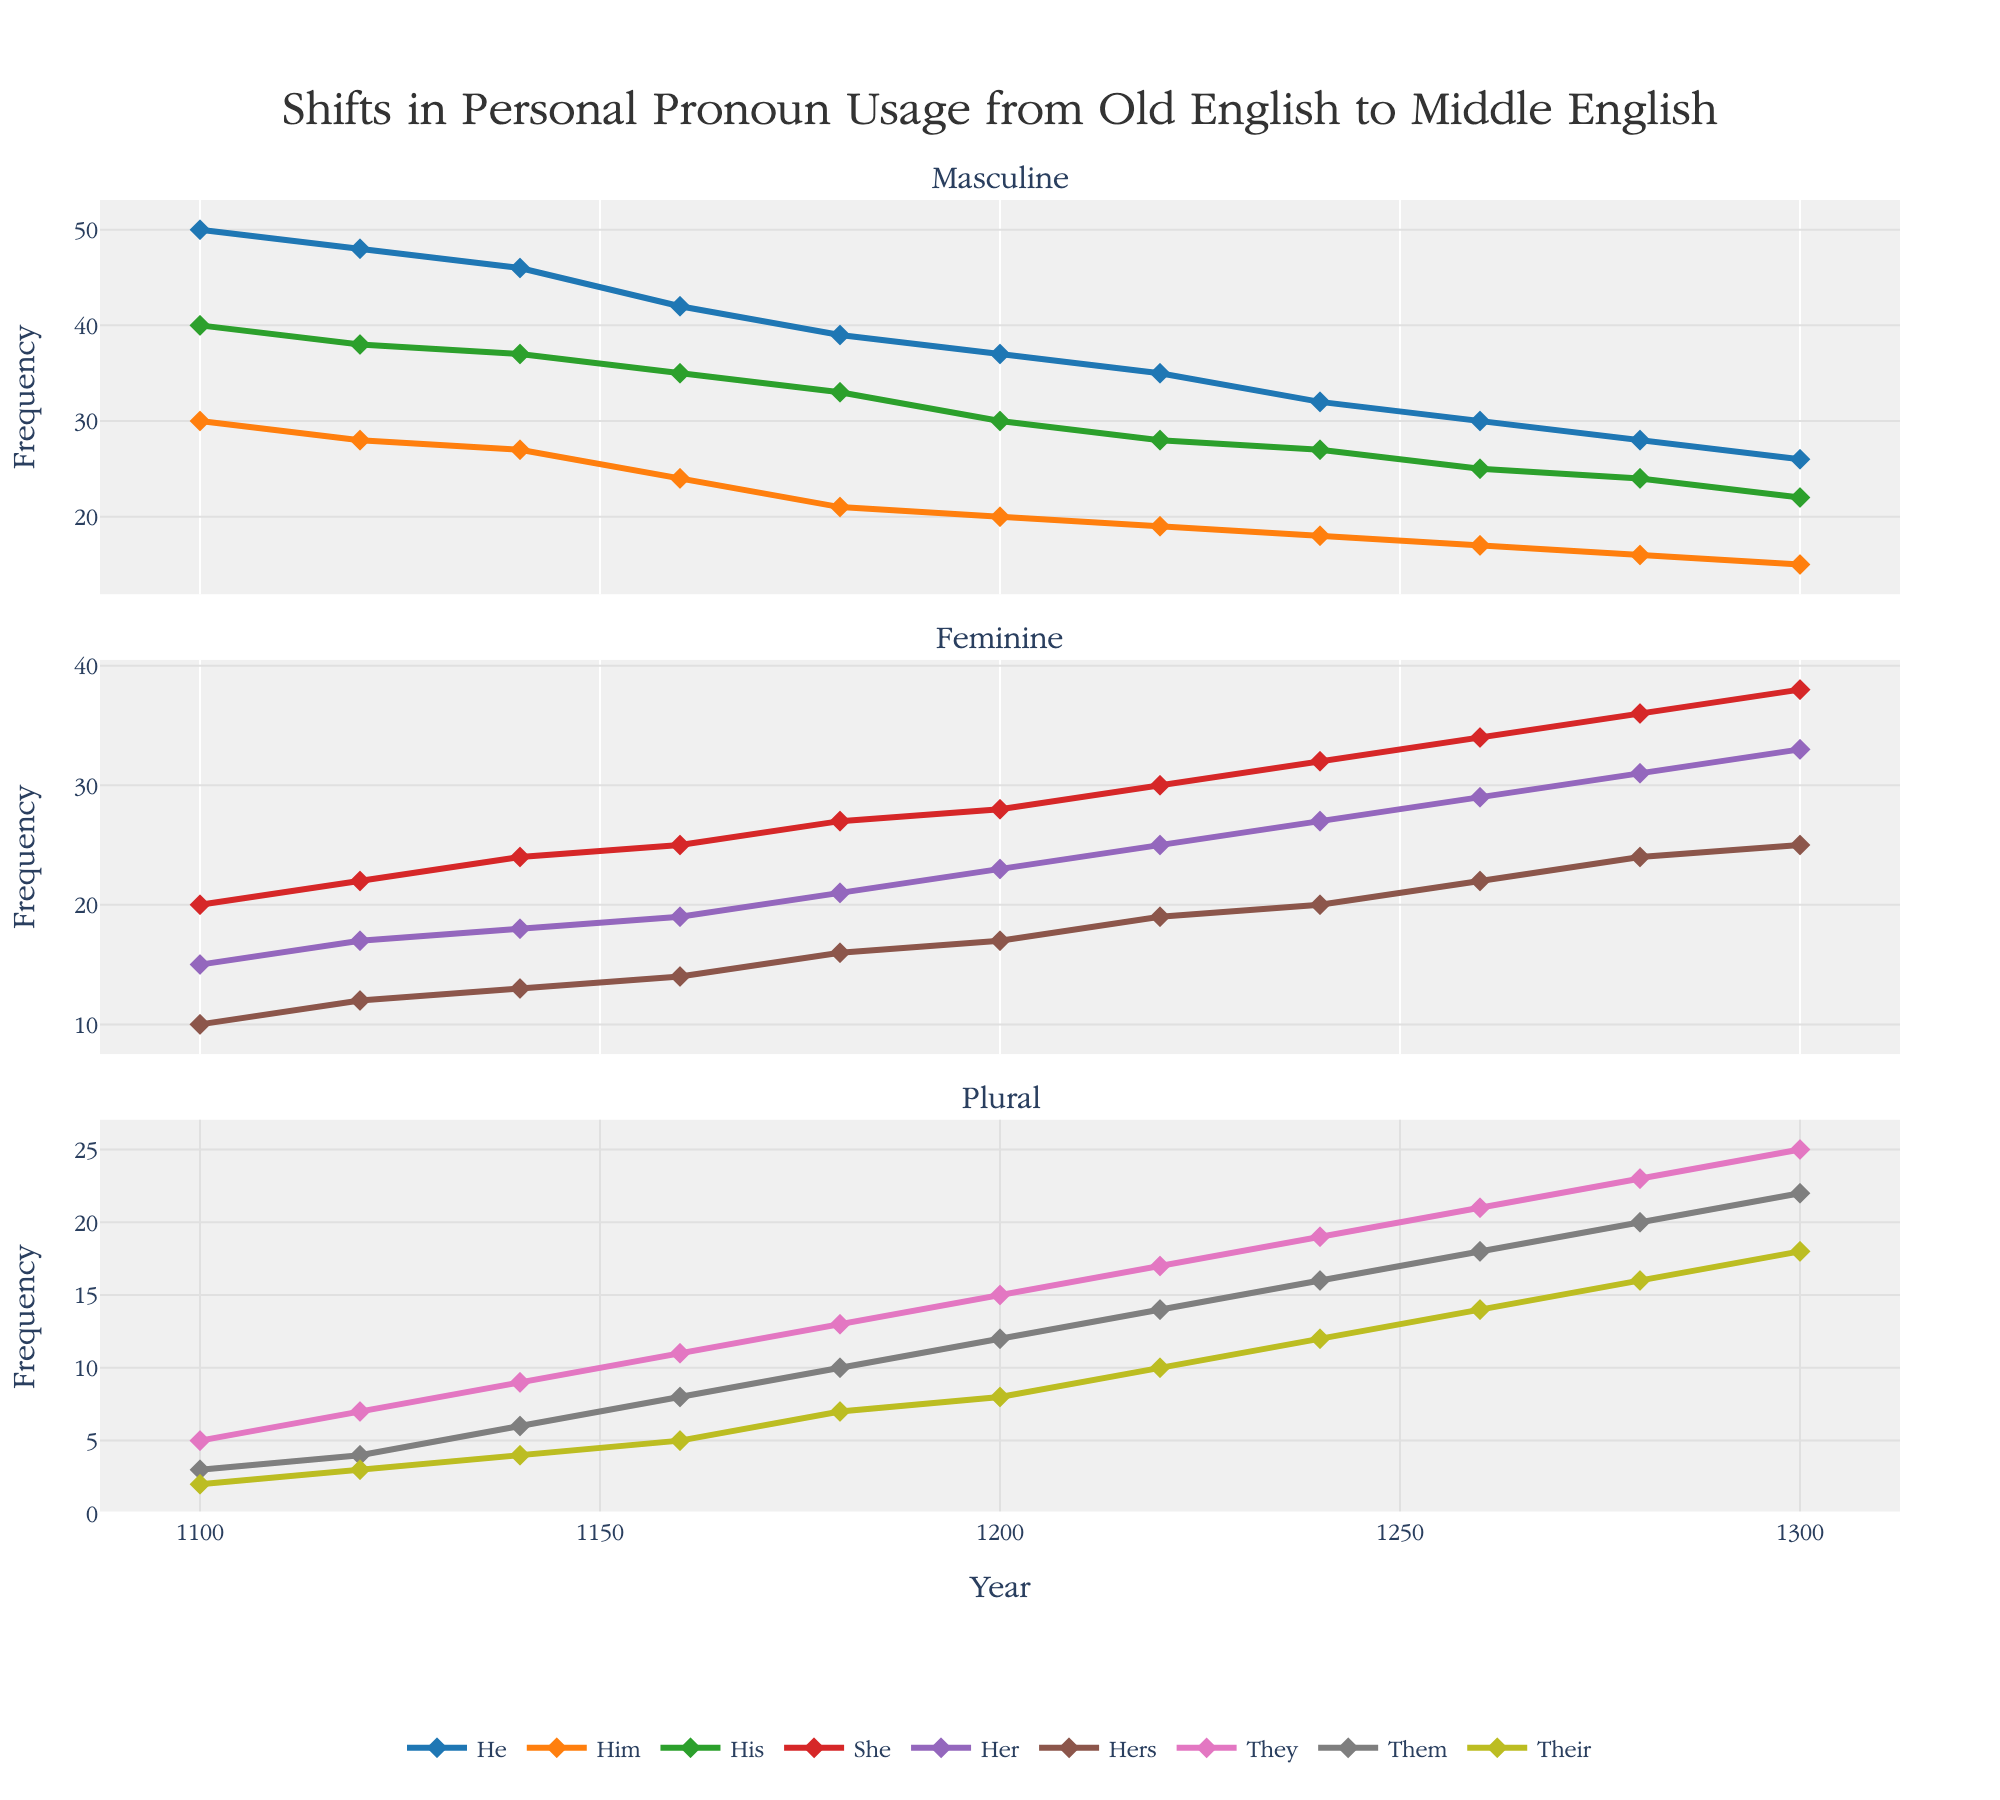Who uses the "Their" pronoun most frequently in the year 1280? Look at the data for 1280 and find the "Their" pronoun in the plural subplot. The frequency of "Their" is highest at this point for that year.
Answer: 16 How did the usage of "Him" change between the years 1100 and 1300? Look at the "Him" pronoun in the masculine subplot and note its frequencies in 1100 and 1300. Subtract the value in 1300 from the value in 1100.
Answer: Decreased by 15 Which pronoun consistently increased in frequency throughout the entire data period from 1100 to 1300? Check each pronoun's trend line across all subplots to find any line that consistently ascends from left to right.
Answer: She Between which two decades did the "Her" pronoun see the most significant increase in usage? Identify the data points of "Her" in the feminine subplot that has the largest positive slope between two consecutive decades by observing the steepness of the connecting lines.
Answer: 1260-1280 What are the two pronouns with the highest frequencies in 1300 in the feminine and plural subplots? Look at the final data point (year 1300) in both the feminine and plural subplots, then identify the pronouns with the highest frequency in each subplot.
Answer: She and They During which decade did "His" usage drop below 30 for the first time, and what was its value then? Find the first data point in the masculine subplot where "His" falls below 30. Note the year and the corresponding value.
Answer: 1200, 30 What is the sum of frequencies of "They" and "Them" in the year 1240? In the plural subplot, add the values of "They" and "Them" for 1240.
Answer: 35 Comparing "He" and "She" pronoun trends, which saw a more significant decline from 1100 to 1300? Determine the values of "He" and "She" in 1100 and 1300, calculate their lost frequencies by subtracting the values in 1300 from those in 1100, and compare the results.
Answer: He How does the usage of "Hers" in 1280 compare to its usage in 1160? Look at the data for "Hers" in both 1160 and 1280, then compare their values.
Answer: Increased by 10 What's the average frequency of "Their" over the entire period from 1100 to 1300? Sum the frequencies of the "Their" pronoun from all years and divide by the total number of data points (11).
Answer: 8 